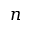Convert formula to latex. <formula><loc_0><loc_0><loc_500><loc_500>n</formula> 